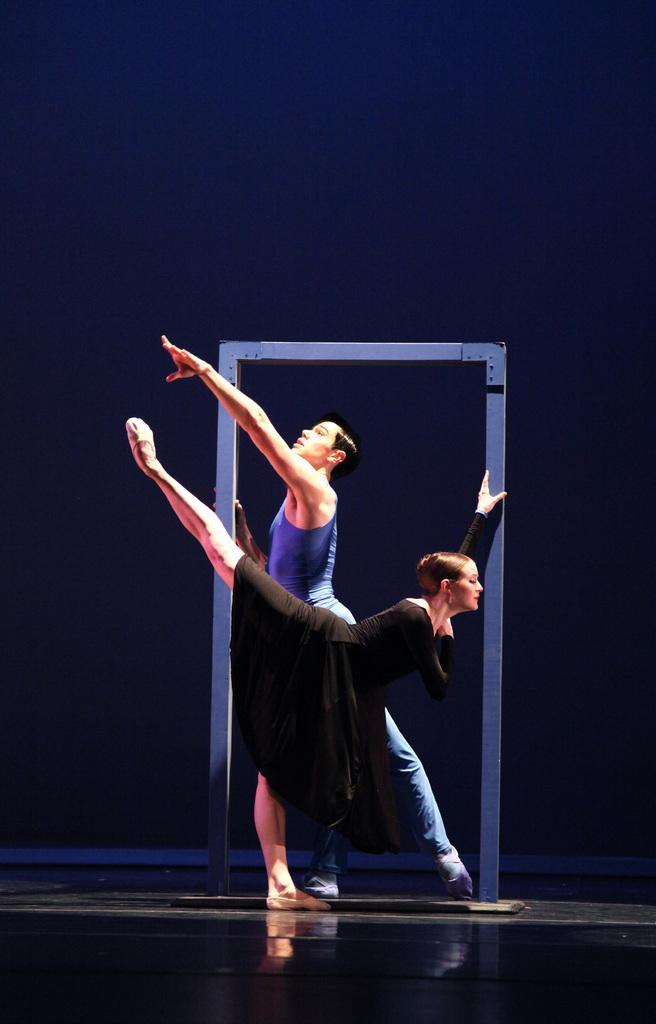Describe this image in one or two sentences. In this image we can see there are two people holding a prop and dancing, the background is dark. 